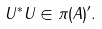<formula> <loc_0><loc_0><loc_500><loc_500>U ^ { * } U \in \pi ( A ) ^ { \prime } .</formula> 